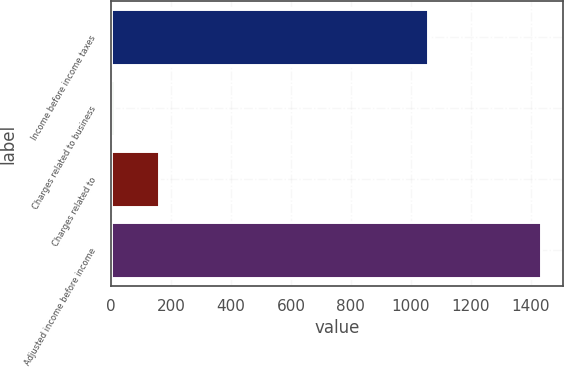<chart> <loc_0><loc_0><loc_500><loc_500><bar_chart><fcel>Income before income taxes<fcel>Charges related to business<fcel>Charges related to<fcel>Adjusted income before income<nl><fcel>1057<fcel>11<fcel>159<fcel>1435<nl></chart> 